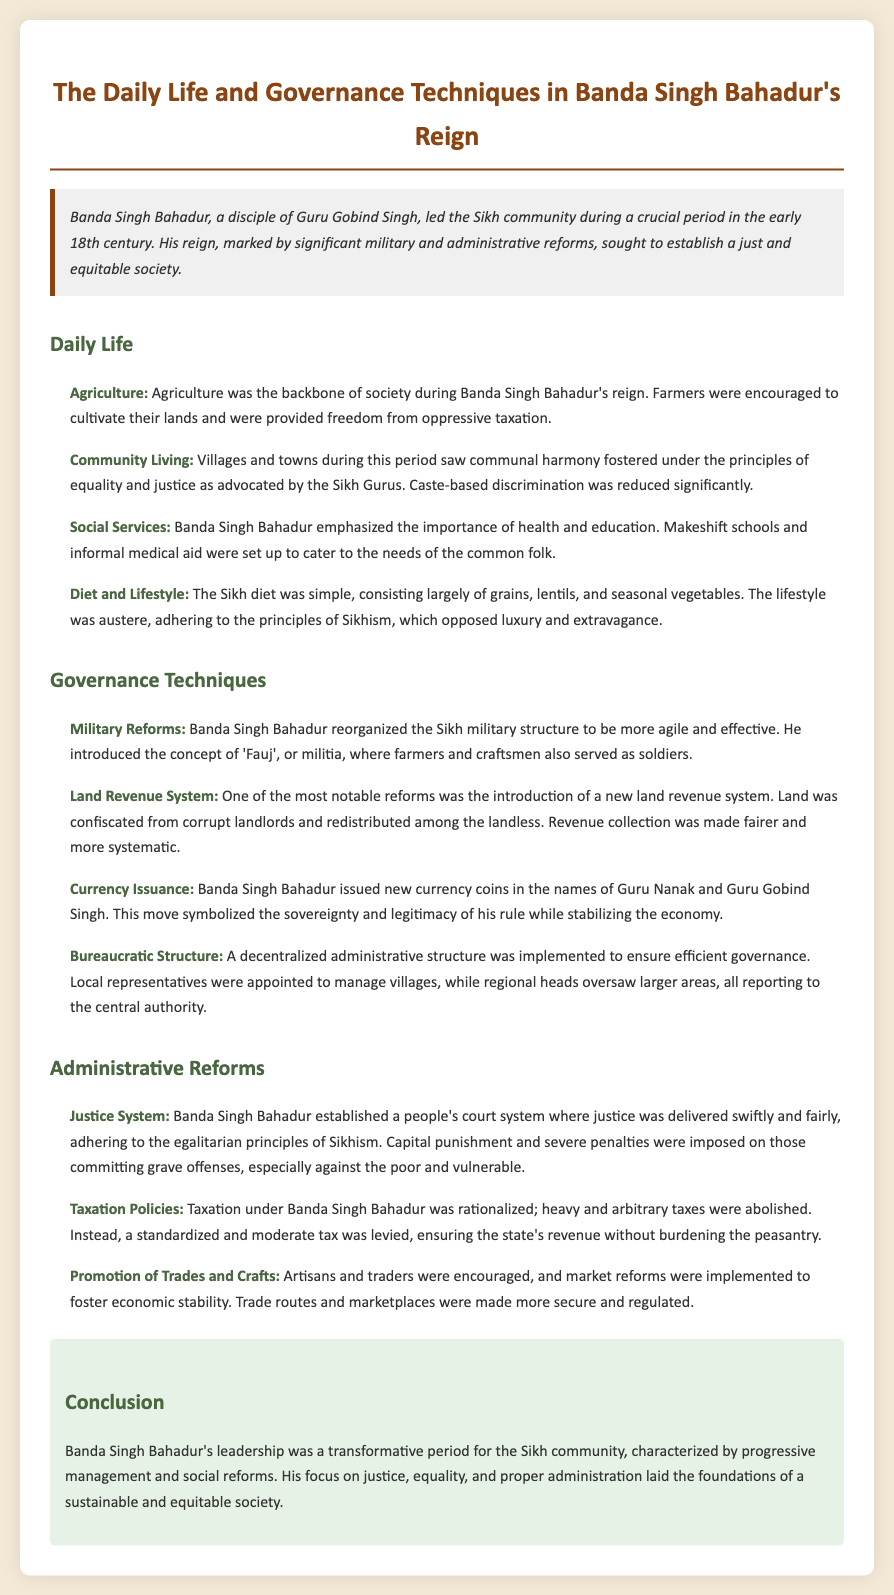What was the primary focus of Banda Singh Bahadur's governance? The document states that Banda Singh Bahadur's reign sought to establish a just and equitable society.
Answer: Just and equitable society How was agriculture treated during Banda Singh Bahadur's reign? Farmers were provided freedom from oppressive taxation and were encouraged to cultivate their lands.
Answer: Freedom from oppressive taxation What was one of the military reforms introduced by Banda Singh Bahadur? He reorganized the Sikh military structure to be more agile and introduced the concept of 'Fauj', or militia.
Answer: 'Fauj', or militia What was the new land revenue system aimed at? The aim was to confiscate land from corrupt landlords and redistribute it among the landless.
Answer: Redistributing among the landless Which two figures were honored in the currency issued by Banda Singh Bahadur? The new currency coins were issued in the names of Guru Nanak and Guru Gobind Singh.
Answer: Guru Nanak and Guru Gobind Singh What kind of court system did Banda Singh Bahadur establish? A people's court system was established where justice was delivered swiftly and fairly.
Answer: People’s court system What taxation approach was adopted during Banda Singh Bahadur's reign? Heavy and arbitrary taxes were abolished, replaced by a standardized and moderate tax.
Answer: Standardized and moderate tax What role did artisans and traders have in Banda Singh Bahadur's administration? Artisans and traders were encouraged, and market reforms were implemented to foster economic stability.
Answer: Encouraged and implemented market reforms 